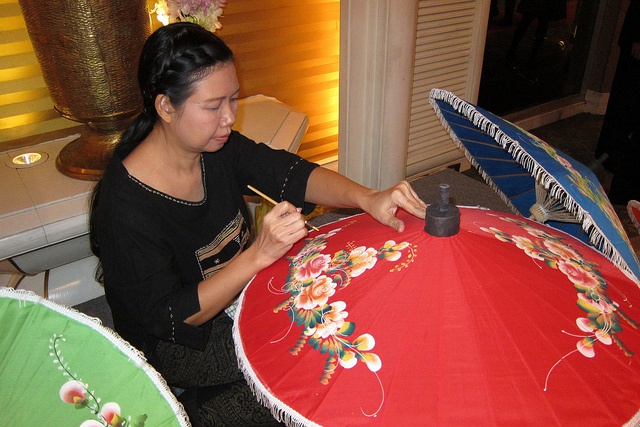Describe the objects in this image and their specific colors. I can see umbrella in orange, brown, and red tones, people in orange, black, brown, salmon, and tan tones, umbrella in orange and lightgreen tones, vase in orange, maroon, black, and olive tones, and umbrella in orange, navy, black, gray, and darkgray tones in this image. 